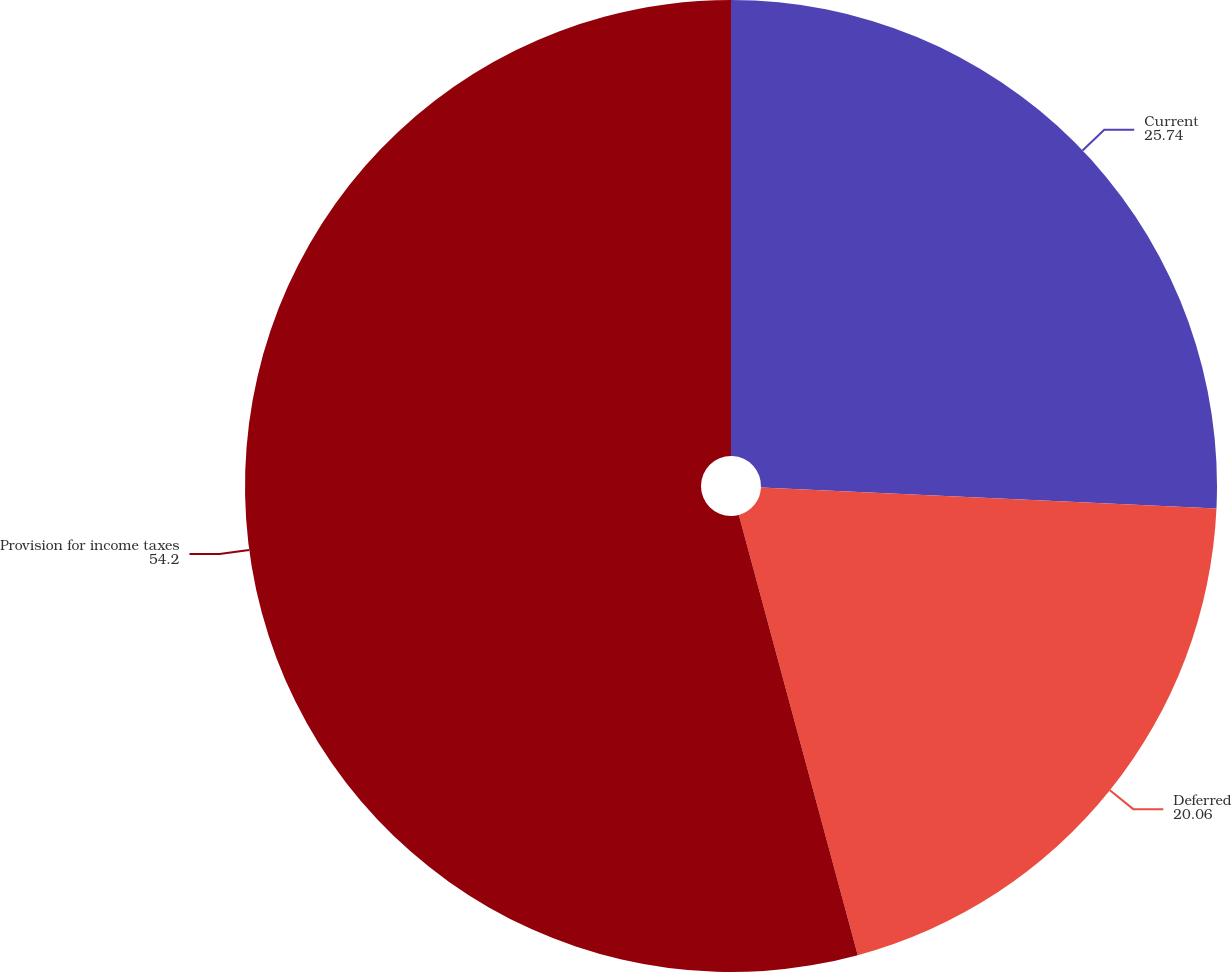Convert chart to OTSL. <chart><loc_0><loc_0><loc_500><loc_500><pie_chart><fcel>Current<fcel>Deferred<fcel>Provision for income taxes<nl><fcel>25.74%<fcel>20.06%<fcel>54.2%<nl></chart> 